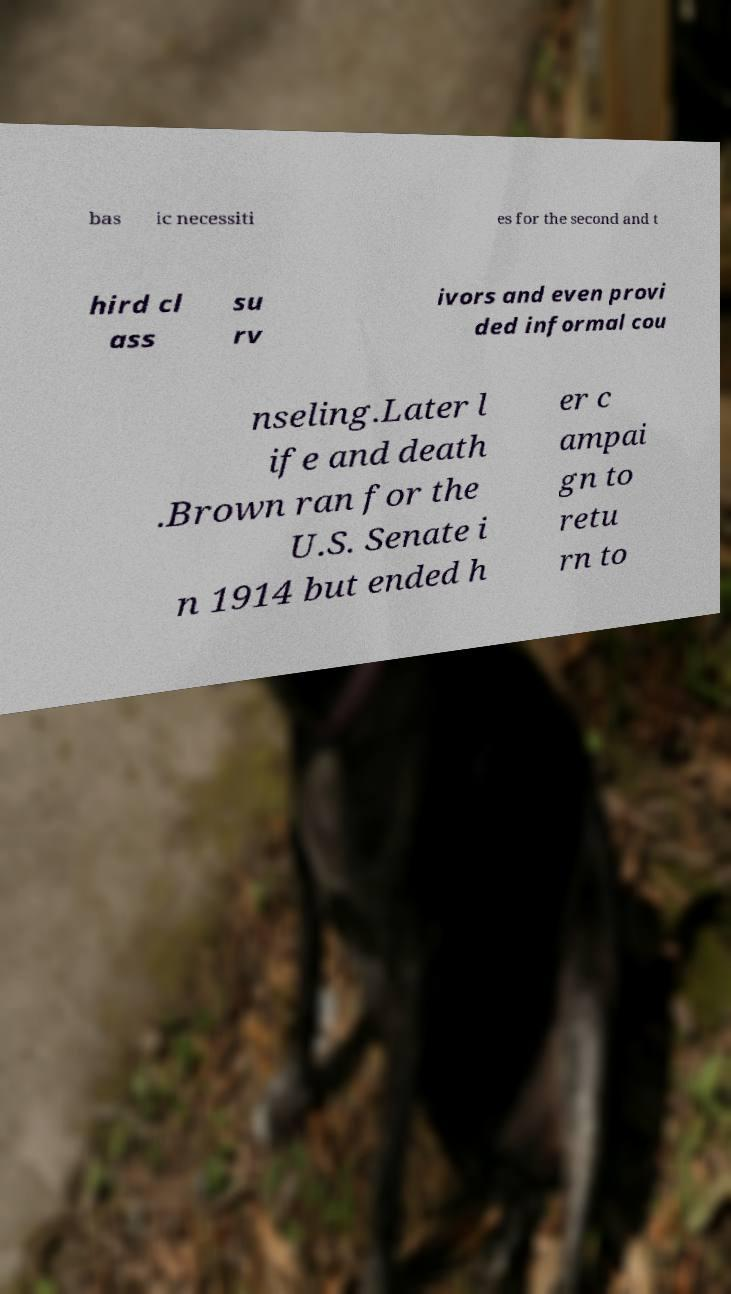Could you extract and type out the text from this image? bas ic necessiti es for the second and t hird cl ass su rv ivors and even provi ded informal cou nseling.Later l ife and death .Brown ran for the U.S. Senate i n 1914 but ended h er c ampai gn to retu rn to 